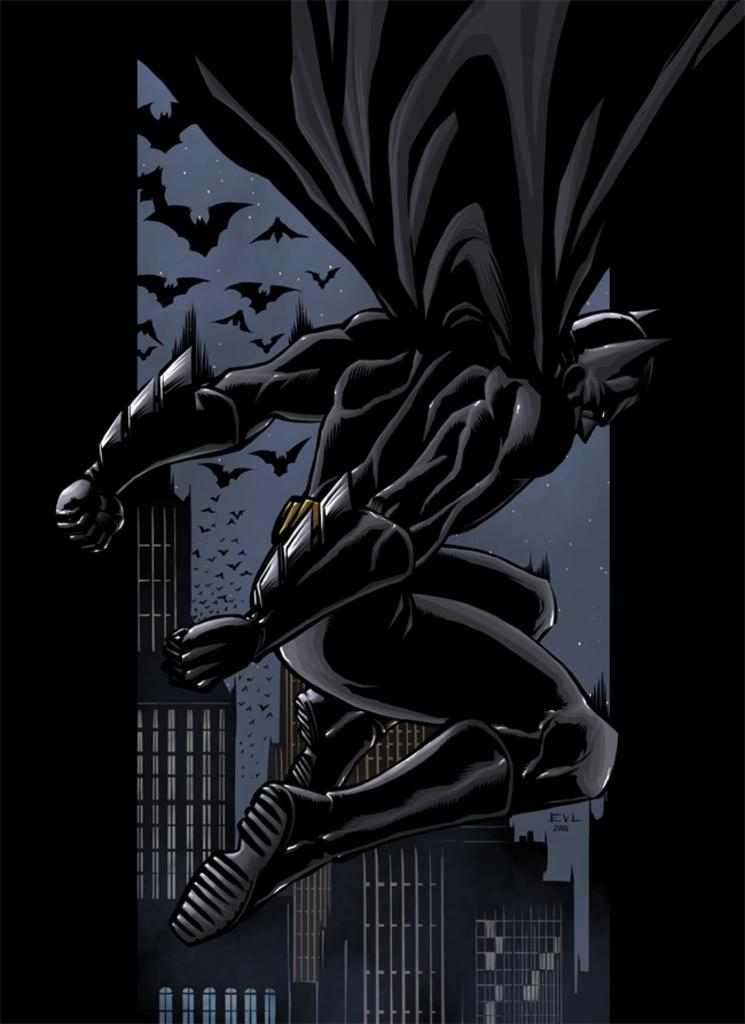Who is the superhero in the foreground of the image? Batman is in the air in the foreground of the image. What can be seen in the sky in the background of the image? There are bats in the sky in the background of the image. What type of structures are visible in the background of the image? There are buildings visible in the background of the image. What type of science experiment is being conducted in the image? There is no science experiment present in the image; it features Batman in the air and bats in the sky. How many trucks are visible in the image? There are no trucks visible in the image. 